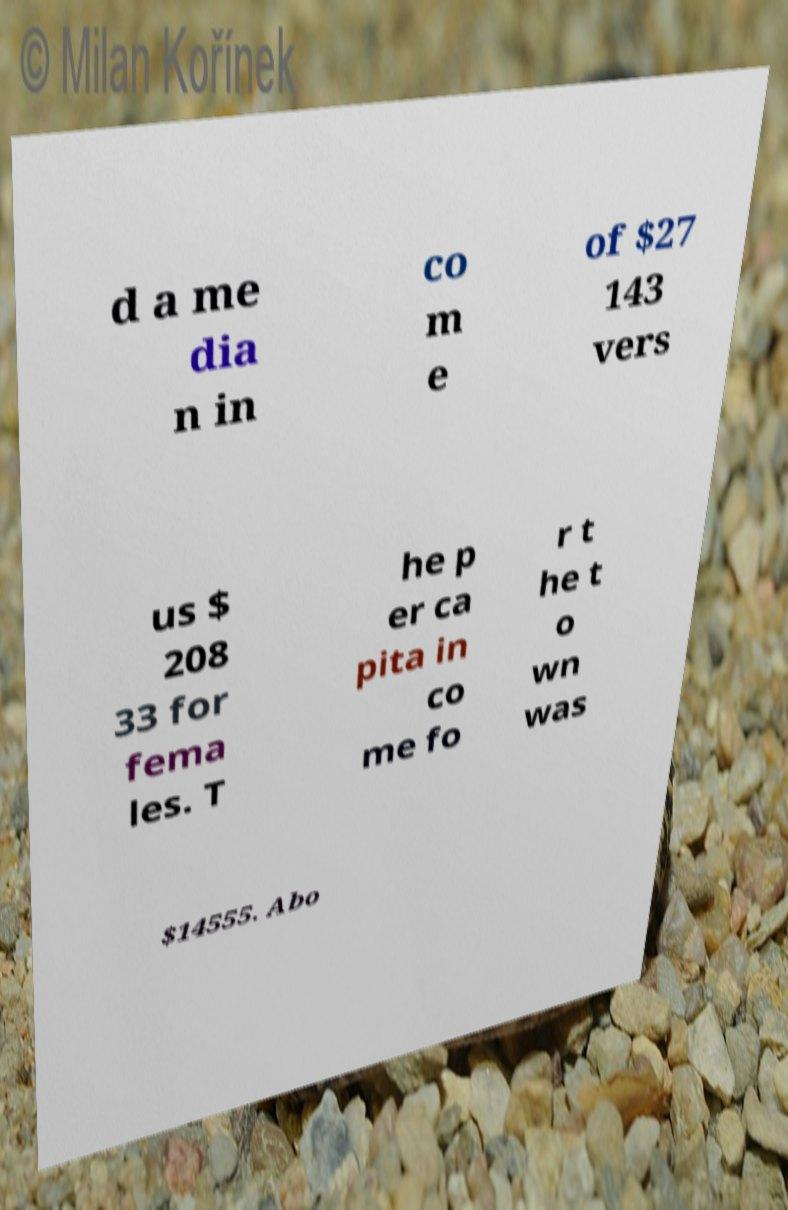Could you assist in decoding the text presented in this image and type it out clearly? d a me dia n in co m e of $27 143 vers us $ 208 33 for fema les. T he p er ca pita in co me fo r t he t o wn was $14555. Abo 